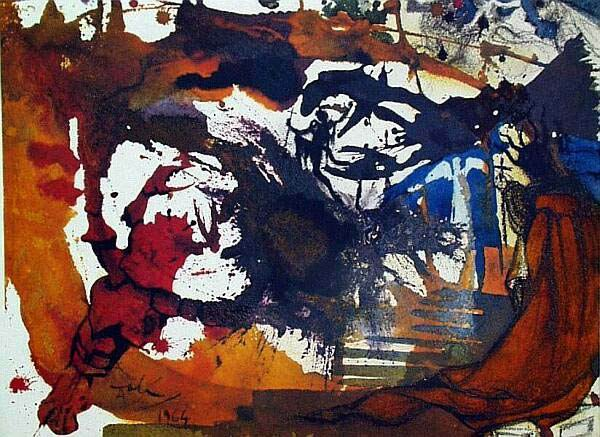Describe the emotion conveyed by the colors and shapes in this abstract artwork. The colors and shapes in this abstract artwork seem to convey a complex blend of emotions. The intense reds and dark hues could be indicative of passion, anger, or perhaps even chaos, while the blues might suggest calmness or melancholy. The erratic, forceful brushstrokes and overlapping shapes convey a sense of movement and energy, hinting at an underlying turbulence or intensity of feeling. Overall, the painting seems to encapsulate a whirlwind of emotions, leaving interpretation open to the viewer's perspective. Can you provide a narrative for the scene depicted in this artwork? Imagine a stormy night in the heart of a bustling city. The city's vibrant energy and intensity are personified through the chaotic blend of colors and dramatic brushstrokes. Amidst the storm, a lone figure stands, highlighted by deep blues and dark shadows, representing solitude and contemplation. The intertwining shapes and colors illustrate the clash of emotions within the individual—conflict, passion, resilience, and tranquility all blending into one intense experience. This visual narrative encourages viewers to ponder the profound and often contradictory emotions that life evokes. What historical art movements might have influenced this piece? This piece appears to be heavily influenced by the Abstract Expressionism movement, prominent in the mid-20th century. Artists like Jackson Pollock and Willem de Kooning come to mind, known for their dynamic and spontaneous methods of creation. The intense use of colors and emphasis on conveying emotion through abstract forms are key characteristics of this movement. Additionally, elements of Surrealism can be perceived in the almost dream-like, non-representational shapes and forms that dominate the composition. The artwork's ability to evoke deep emotions and leave interpretation open to the viewer aligns well with the ideologies of these movements. 